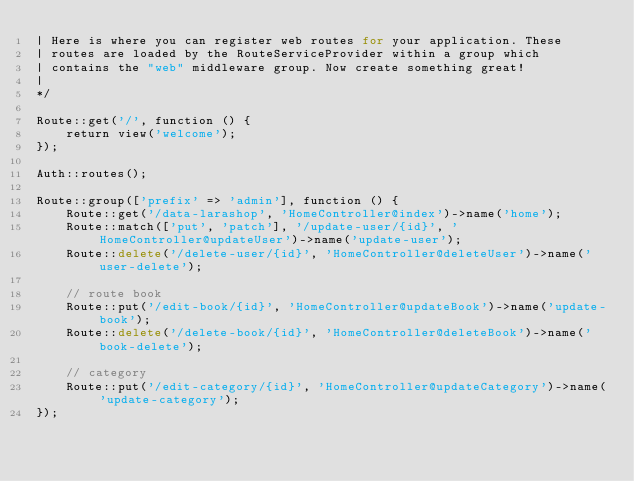<code> <loc_0><loc_0><loc_500><loc_500><_PHP_>| Here is where you can register web routes for your application. These
| routes are loaded by the RouteServiceProvider within a group which
| contains the "web" middleware group. Now create something great!
|
*/

Route::get('/', function () {
    return view('welcome');
});

Auth::routes();

Route::group(['prefix' => 'admin'], function () {
    Route::get('/data-larashop', 'HomeController@index')->name('home');
    Route::match(['put', 'patch'], '/update-user/{id}', 'HomeController@updateUser')->name('update-user');
    Route::delete('/delete-user/{id}', 'HomeController@deleteUser')->name('user-delete');

    // route book
    Route::put('/edit-book/{id}', 'HomeController@updateBook')->name('update-book');
    Route::delete('/delete-book/{id}', 'HomeController@deleteBook')->name('book-delete');

    // category
    Route::put('/edit-category/{id}', 'HomeController@updateCategory')->name('update-category');
});
</code> 